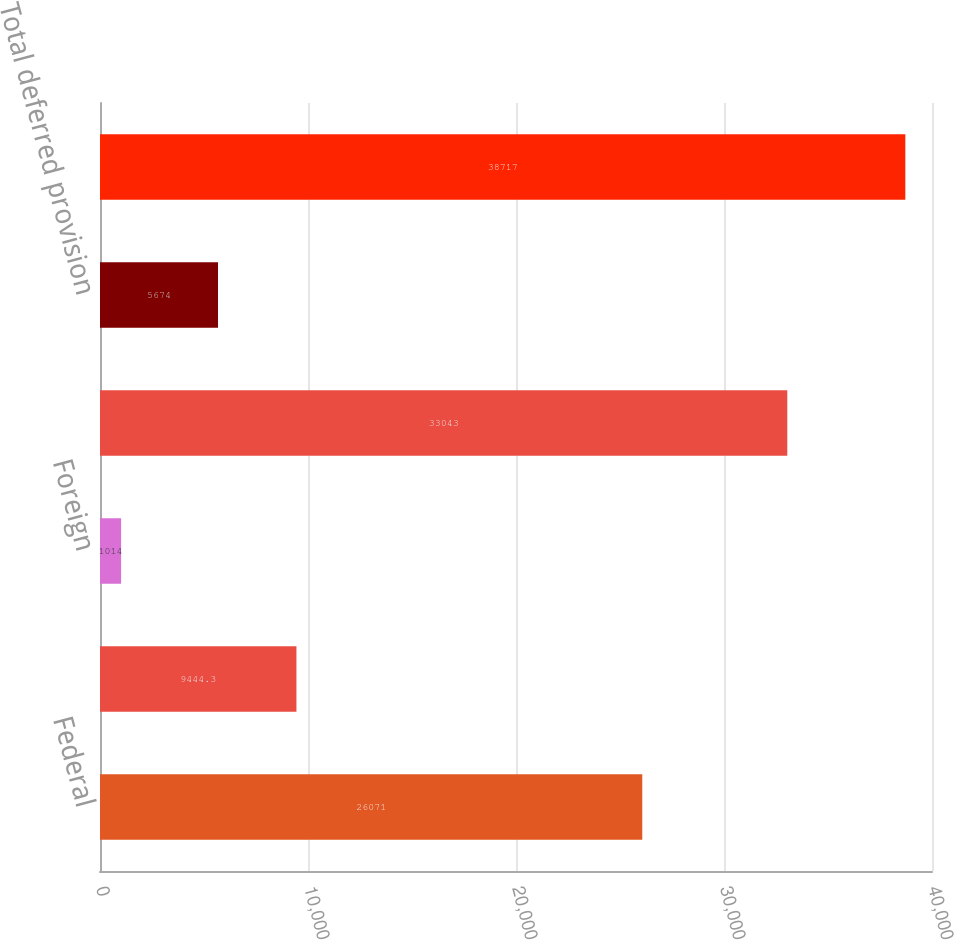<chart> <loc_0><loc_0><loc_500><loc_500><bar_chart><fcel>Federal<fcel>State and local<fcel>Foreign<fcel>Total current provision<fcel>Total deferred provision<fcel>Provision for income taxes<nl><fcel>26071<fcel>9444.3<fcel>1014<fcel>33043<fcel>5674<fcel>38717<nl></chart> 